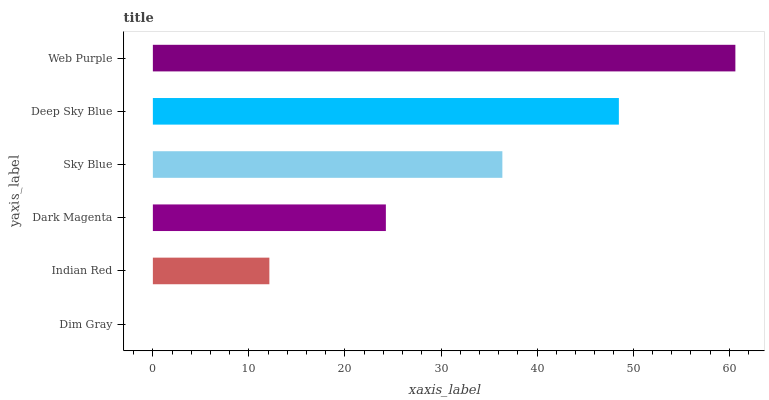Is Dim Gray the minimum?
Answer yes or no. Yes. Is Web Purple the maximum?
Answer yes or no. Yes. Is Indian Red the minimum?
Answer yes or no. No. Is Indian Red the maximum?
Answer yes or no. No. Is Indian Red greater than Dim Gray?
Answer yes or no. Yes. Is Dim Gray less than Indian Red?
Answer yes or no. Yes. Is Dim Gray greater than Indian Red?
Answer yes or no. No. Is Indian Red less than Dim Gray?
Answer yes or no. No. Is Sky Blue the high median?
Answer yes or no. Yes. Is Dark Magenta the low median?
Answer yes or no. Yes. Is Dim Gray the high median?
Answer yes or no. No. Is Dim Gray the low median?
Answer yes or no. No. 